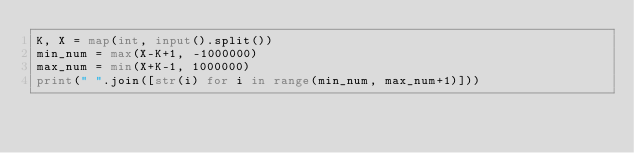Convert code to text. <code><loc_0><loc_0><loc_500><loc_500><_Python_>K, X = map(int, input().split())
min_num = max(X-K+1, -1000000)
max_num = min(X+K-1, 1000000)
print(" ".join([str(i) for i in range(min_num, max_num+1)]))</code> 